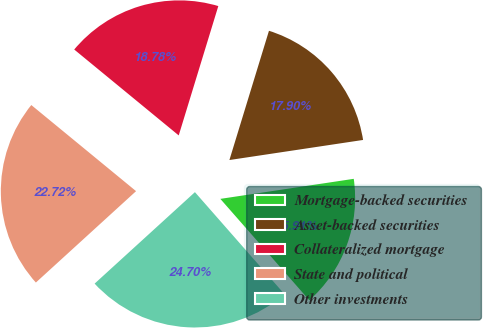Convert chart. <chart><loc_0><loc_0><loc_500><loc_500><pie_chart><fcel>Mortgage-backed securities<fcel>Asset-backed securities<fcel>Collateralized mortgage<fcel>State and political<fcel>Other investments<nl><fcel>15.91%<fcel>17.9%<fcel>18.78%<fcel>22.72%<fcel>24.7%<nl></chart> 